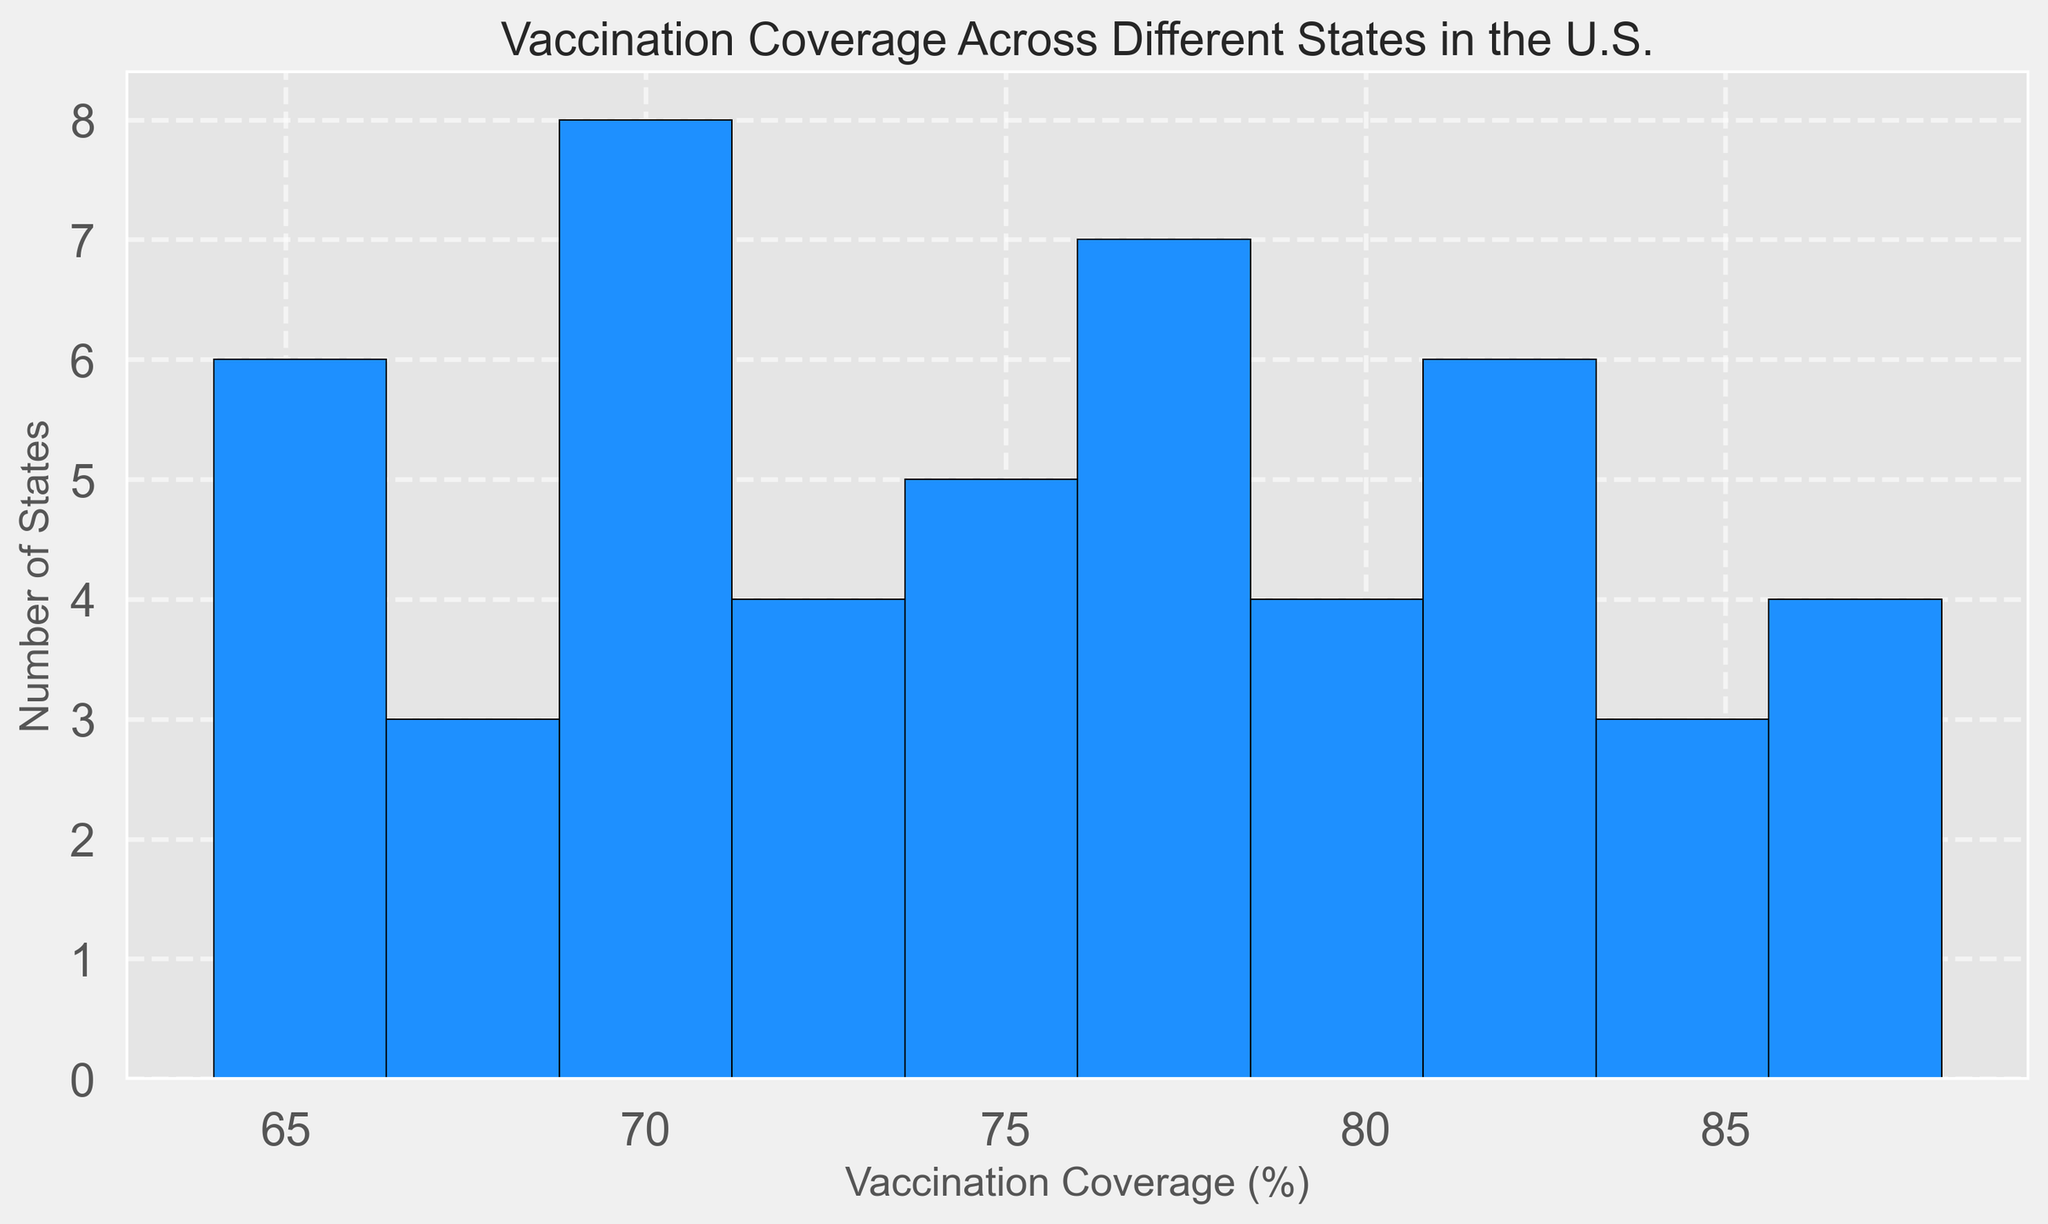What's the most common range of vaccination coverage among states? From the histogram's distribution, the highest bar represents the most common range. This bar covers the vaccination coverage range of 70-75%. Therefore, most states have vaccination coverage within 70-75%.
Answer: 70-75% What is the maximum vaccination coverage percentage seen in the states? The histogram's rightmost bar extends to the maximum vaccination coverage percentage. This coverage reaches up to 88%.
Answer: 88% Which range of vaccination coverage has the least number of states? The histogram's lowest bar signifies the coverage range with the fewest states. This is the range of 60-65%, indicating fewer states fall within this coverage range.
Answer: 60-65% How many states have a vaccination coverage of 80% or higher? By visually inspecting the histogram, count the bars from 80% onwards. Since the bins cover multiple ranges, the bars corresponding to 80-85%, 85-90% coverages show that there are several states.
Answer: 13 states Does any state have a vaccination coverage below 60%? The histogram start range is from 60%, and no bar representing the 55-60% range confirms that no state falls below 60% in vaccination coverage.
Answer: No What is the median range for the vaccination coverage? Since the histogram appears symmetric and analyzing the bars distribution along with central tendency measures, the median range likely falls in the middle bar, which is around 75-80%. This involves counting the states distribution evenly.
Answer: 75-80% How does the number of states in the 70-75% range compare to those in the 75-80% range? Visually comparing the heights of bars corresponding to these two ranges, it's evident that the 70-75% range has a slightly higher or similar height compared to the 75-80% range.
Answer: 70-75% range has about the same number of states or slightly more What color is used to represent the bars in the histogram? The histogram uses a single fill color for all bars. By observing the histogram, we can see that the bars are filled with dodger blue color.
Answer: Dodger blue Within which range do most states fall under? Observing the tallest bar, the range for the highest number of states falls under either 70-75% or 75-80%.
Answer: 70-75% range 